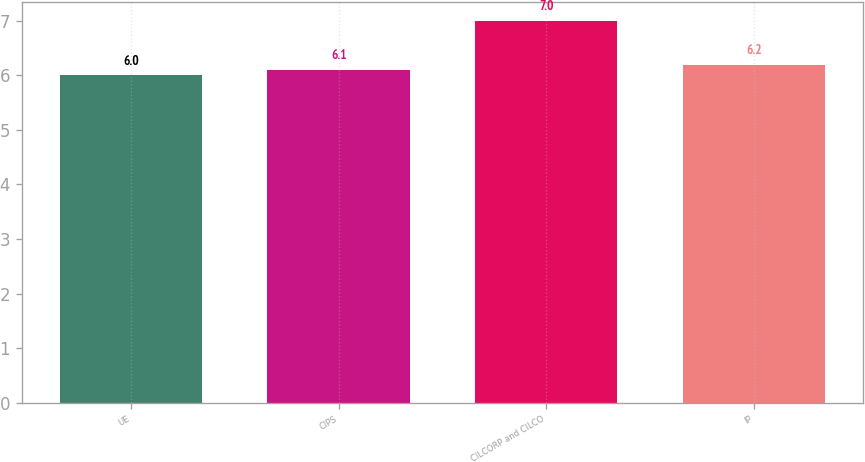Convert chart to OTSL. <chart><loc_0><loc_0><loc_500><loc_500><bar_chart><fcel>UE<fcel>CIPS<fcel>CILCORP and CILCO<fcel>IP<nl><fcel>6<fcel>6.1<fcel>7<fcel>6.2<nl></chart> 